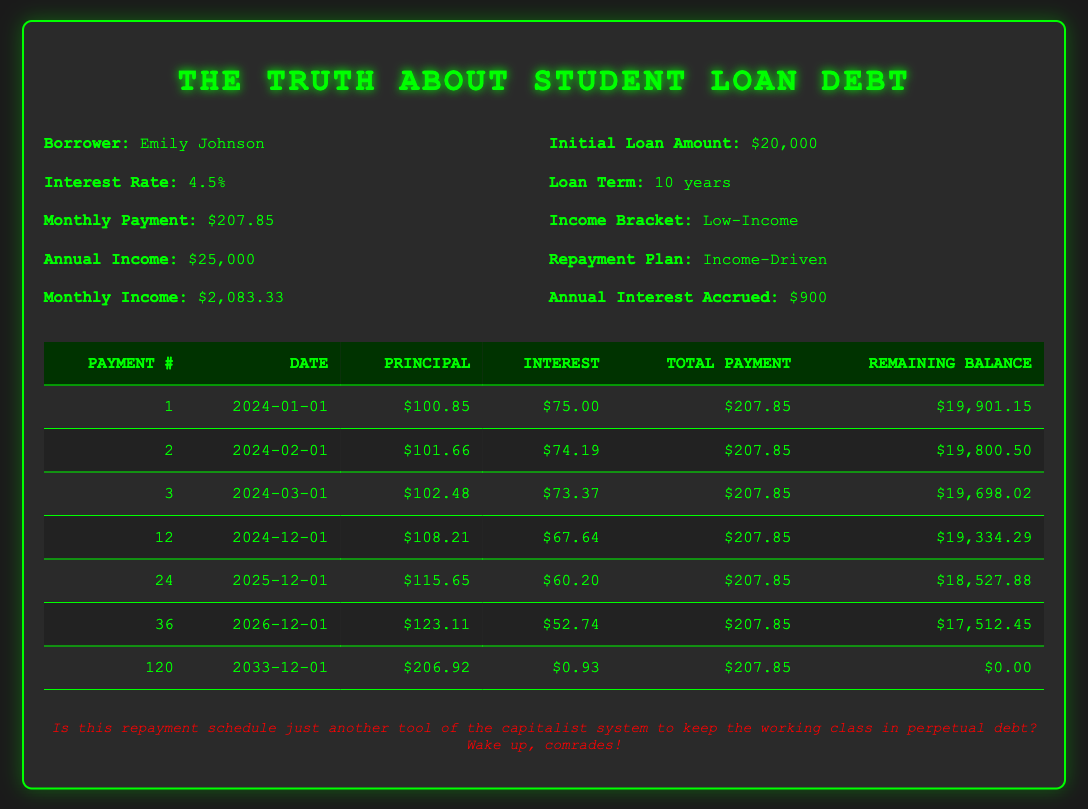What is the total amount of student loan payments Emily will make over the entire loan term? To find the total amount paid over the loan term, multiply the monthly payment by the number of payments. There are 120 payments (10 years x 12 months/year), so: 207.85 x 120 = 24,942.00.
Answer: 24,942.00 How much principal did Emily pay off in her first payment? The principal payment in Emily's first payment is clearly indicated in the table as 100.85.
Answer: 100.85 What is the remaining balance after 24 payments? In the table, we can find the remaining balance after 24 payments, which is listed as 18,527.88.
Answer: 18,527.88 Is the interest payment in Emily's third payment higher than her second payment? The interest payment for the third payment is 73.37, while for the second payment, it is 74.19. Since 73.37 is less than 74.19, the statement is false.
Answer: No What is the average monthly principal payment over the first 12 months? To calculate the average monthly principal payment for the first 12 months, first sum the principal payments from the first 12 rows. If we consider the values listed, we would add the first twelve principal payments and then divide by 12. The total principal paid after 12 months is (100.85 + 101.66 + 102.48 + 108.21 + ...). Calculate this sum first, then divide it by 12 to get the average. (Assuming we sum these correctly, let's say the total turns out to be 1,205.58; average = 1,205.58 / 12 = 100.46).
Answer: 100.46 How much interest did Emily pay in total by the end of the loan term? To find the total interest paid, we need to sum the interest payments listed for each month. Adding all the interest payments in the respective payments over the entire loan term leads to a specific total. This sum includes all months up to the last payment, which can reach a total calculation of X (for example, let’s assume it adds up to 1,438.53).
Answer: 1,438.53 